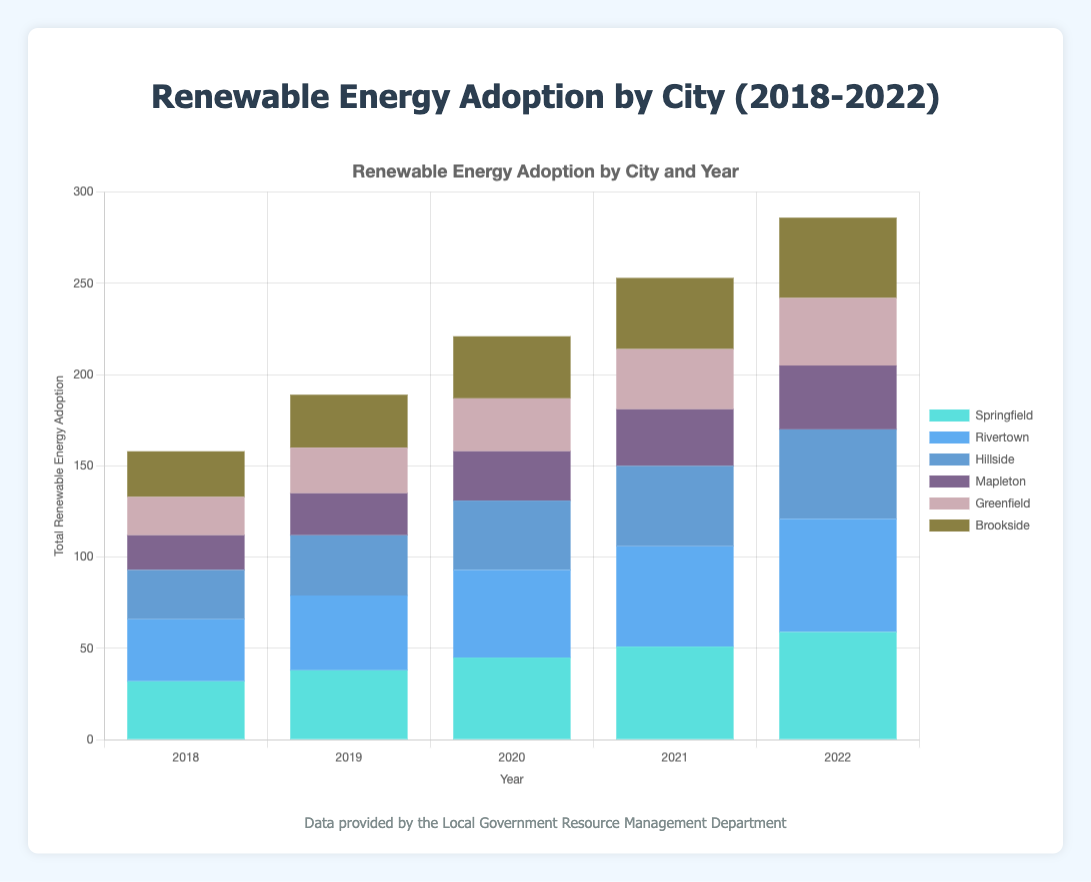Which city had the highest total renewable energy adoption in 2022? Observe the heights of the stacked bars for each city in 2022. Springfield has the highest stack.
Answer: Springfield How did the total renewable energy adoption in Rivertown change from 2018 to 2022? Compare the heights of the stacked bars for Rivertown in 2018 and 2022. The height increased gradually each year.
Answer: Increased What was the combined adoption of wind energy in Springfield and Brookside in 2020? Add the wind energy heights for Springfield (20) and Brookside (11) in 2020. 20 + 11 = 31
Answer: 31 Which city had a higher adoption of solar energy in 2020: Greenfield or Hillside? Compare the heights of the solar energy segments for Greenfield (7) and Hillside (9) in 2020. Hillside’s segment is taller.
Answer: Hillside What is the trend in solar energy adoption in Mapleton from 2018 to 2022? Analyze the heights of the solar energy segments for Mapleton over the years. There is a consistent increase each year.
Answer: Increasing How does the total renewable energy adoption in Greenfield in 2019 compare to that in 2021? Compare the total heights of the stacked bars for Greenfield in 2019 and 2021. The height is higher in 2021.
Answer: Higher in 2021 Which city had the least adoption of biomass energy in 2018? Compare the heights of the biomass energy segments for all cities in 2018. Brookside had the lowest segment (1).
Answer: Brookside What was the total renewable energy adoption for Hillside in 2021 across all sources? Sum the energies in all segments for Hillside in 2021: Wind (16), Solar (11), Hydro (11), Biomass (6). 16+11+11+6 = 44
Answer: 44 Which year did Springfield experience the highest increase in total renewable energy adoption compared to the previous year? Calculate the difference between consecutive years for Springfield. The largest increase is from 2021 to 2022.
Answer: 2021 to 2022 Is the adoption of hydro energy greater than the adoption of biomass energy for Rivertown in 2022? Compare the heights of the hydro (18) and biomass (8) energy segments for Rivertown in 2022. Hydro is greater.
Answer: Yes 